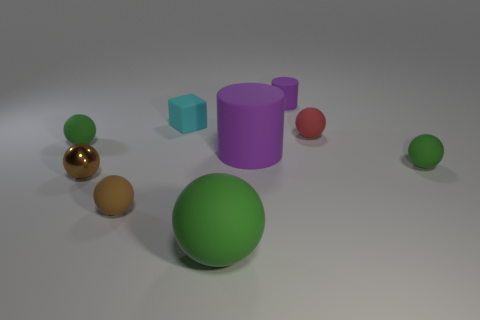What number of things are rubber blocks or large brown blocks?
Your response must be concise. 1. There is a rubber sphere that is both on the left side of the big green object and behind the small brown rubber thing; what size is it?
Your response must be concise. Small. Are there fewer large cylinders behind the small shiny object than large matte objects?
Offer a very short reply. Yes. The tiny brown object that is the same material as the small red ball is what shape?
Provide a succinct answer. Sphere. There is a small green rubber object that is right of the small rubber cylinder; is it the same shape as the tiny green object on the left side of the red rubber ball?
Your answer should be very brief. Yes. Are there fewer tiny brown objects to the left of the small shiny object than rubber things that are on the left side of the cyan block?
Keep it short and to the point. Yes. There is another small thing that is the same color as the shiny object; what shape is it?
Your response must be concise. Sphere. How many matte cubes are the same size as the red rubber sphere?
Your answer should be compact. 1. Are the small brown thing that is on the left side of the tiny brown rubber sphere and the cyan object made of the same material?
Offer a terse response. No. Are any green blocks visible?
Your answer should be very brief. No. 